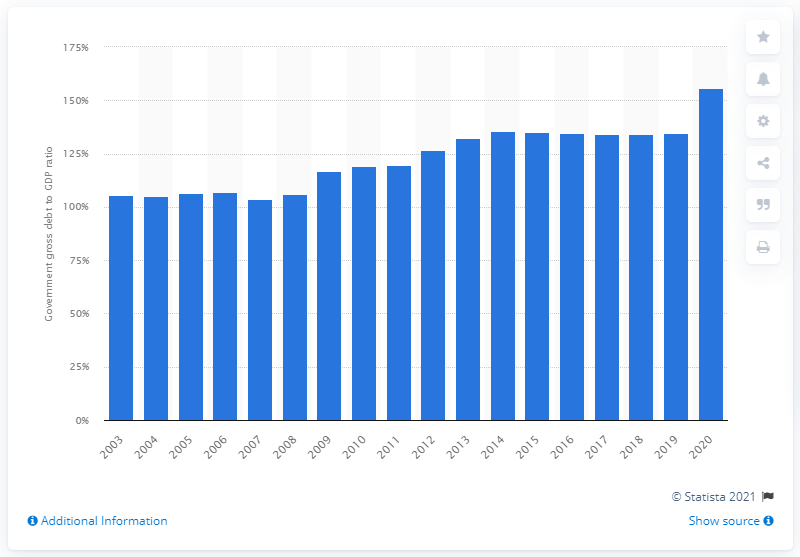Give some essential details in this illustration. In 2020, the government debt of Italy accounted for approximately 155.81% of the country's Gross Domestic Product (GDP). 